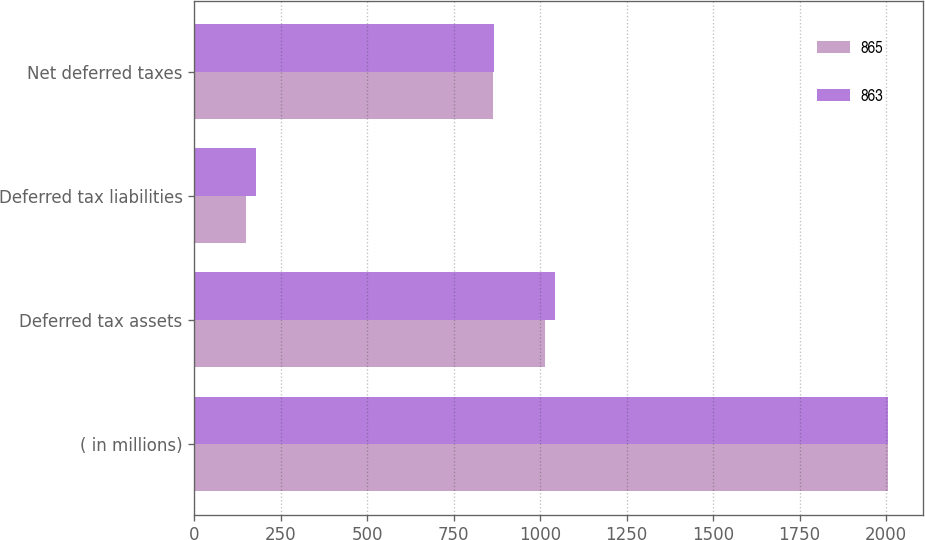<chart> <loc_0><loc_0><loc_500><loc_500><stacked_bar_chart><ecel><fcel>( in millions)<fcel>Deferred tax assets<fcel>Deferred tax liabilities<fcel>Net deferred taxes<nl><fcel>865<fcel>2007<fcel>1013<fcel>150<fcel>863<nl><fcel>863<fcel>2006<fcel>1042<fcel>177<fcel>865<nl></chart> 